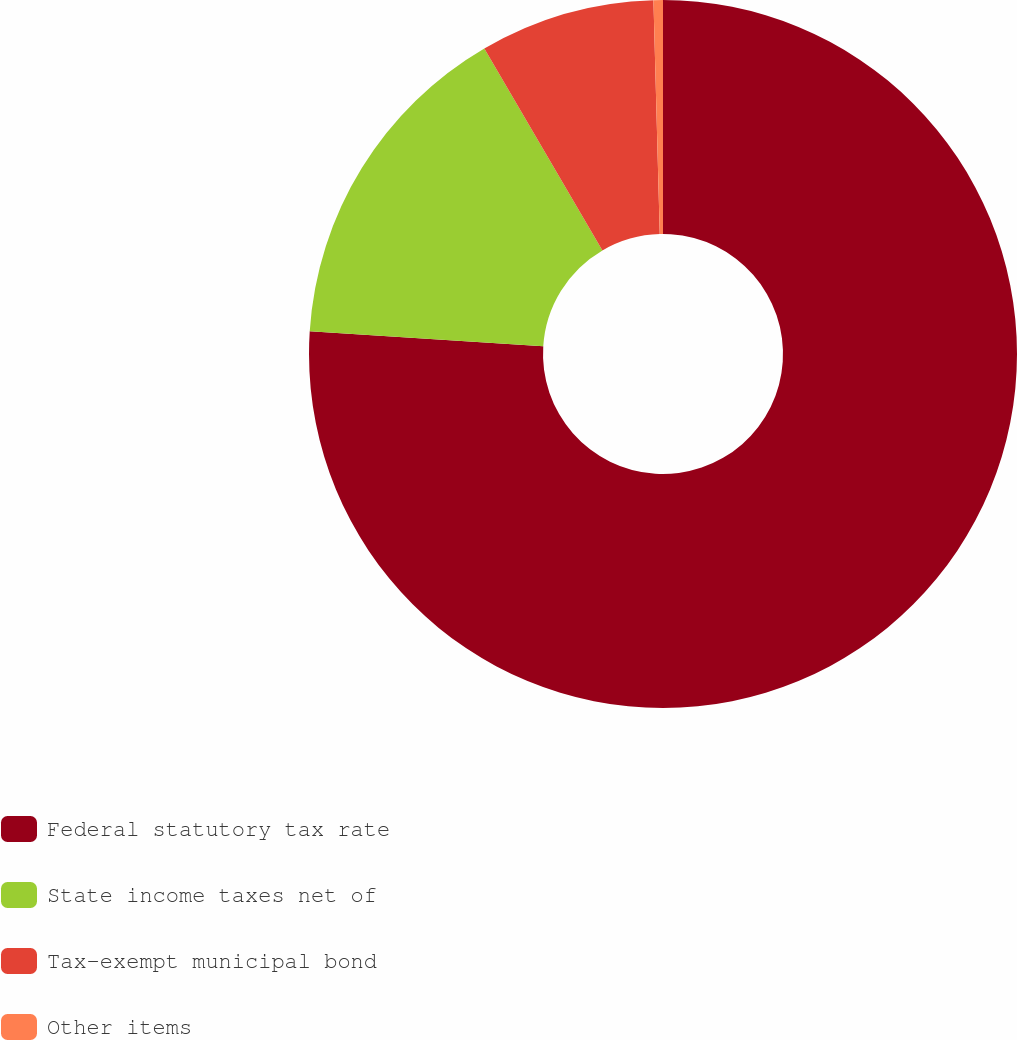Convert chart. <chart><loc_0><loc_0><loc_500><loc_500><pie_chart><fcel>Federal statutory tax rate<fcel>State income taxes net of<fcel>Tax-exempt municipal bond<fcel>Other items<nl><fcel>76.02%<fcel>15.55%<fcel>7.99%<fcel>0.43%<nl></chart> 